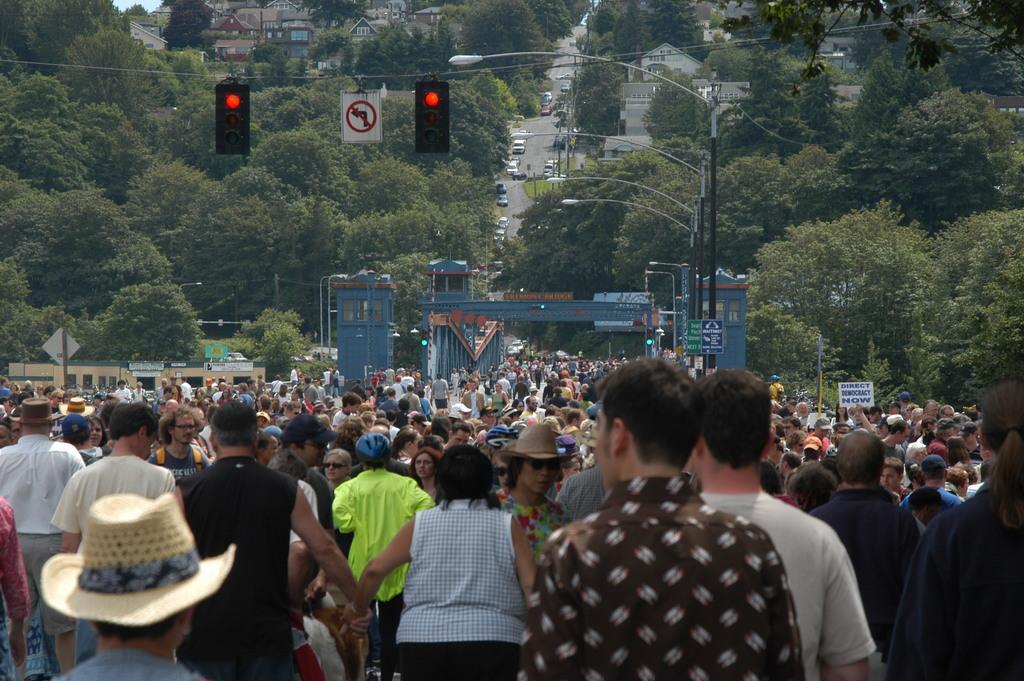Could you give a brief overview of what you see in this image? In this image I can see many people. There are traffic signals and sign boards. There are trees and there are vehicles on the road. There are buildings at the back. 